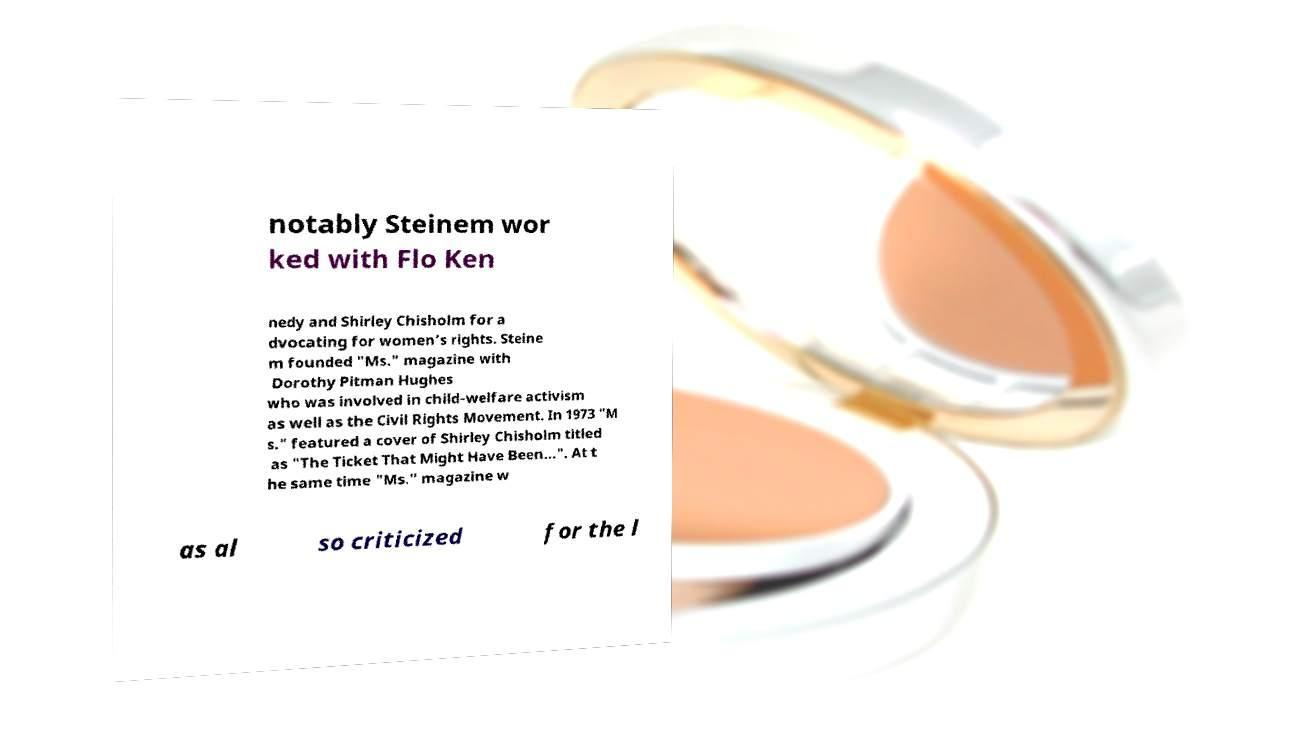There's text embedded in this image that I need extracted. Can you transcribe it verbatim? notably Steinem wor ked with Flo Ken nedy and Shirley Chisholm for a dvocating for women’s rights. Steine m founded "Ms." magazine with Dorothy Pitman Hughes who was involved in child-welfare activism as well as the Civil Rights Movement. In 1973 "M s." featured a cover of Shirley Chisholm titled as "The Ticket That Might Have Been…". At t he same time "Ms." magazine w as al so criticized for the l 